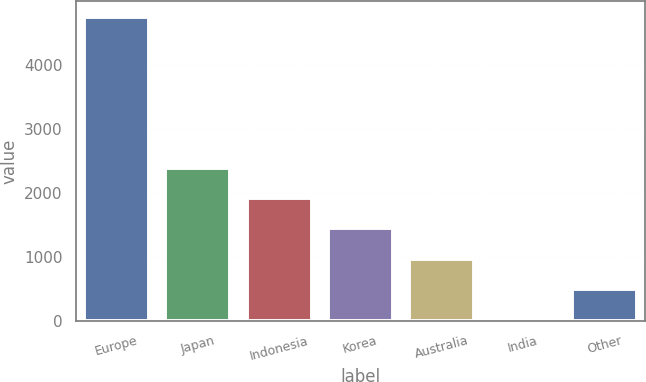<chart> <loc_0><loc_0><loc_500><loc_500><bar_chart><fcel>Europe<fcel>Japan<fcel>Indonesia<fcel>Korea<fcel>Australia<fcel>India<fcel>Other<nl><fcel>4756<fcel>2394<fcel>1921.6<fcel>1449.2<fcel>976.8<fcel>32<fcel>504.4<nl></chart> 